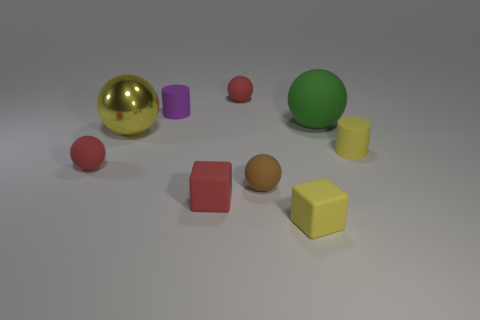Subtract all blue cubes. How many red balls are left? 2 Subtract all big metal balls. How many balls are left? 4 Add 1 small gray rubber objects. How many objects exist? 10 Subtract all green balls. How many balls are left? 4 Subtract all cubes. How many objects are left? 7 Subtract all red balls. Subtract all green cubes. How many balls are left? 3 Subtract all rubber spheres. Subtract all brown balls. How many objects are left? 4 Add 3 purple cylinders. How many purple cylinders are left? 4 Add 3 tiny purple blocks. How many tiny purple blocks exist? 3 Subtract 0 blue balls. How many objects are left? 9 